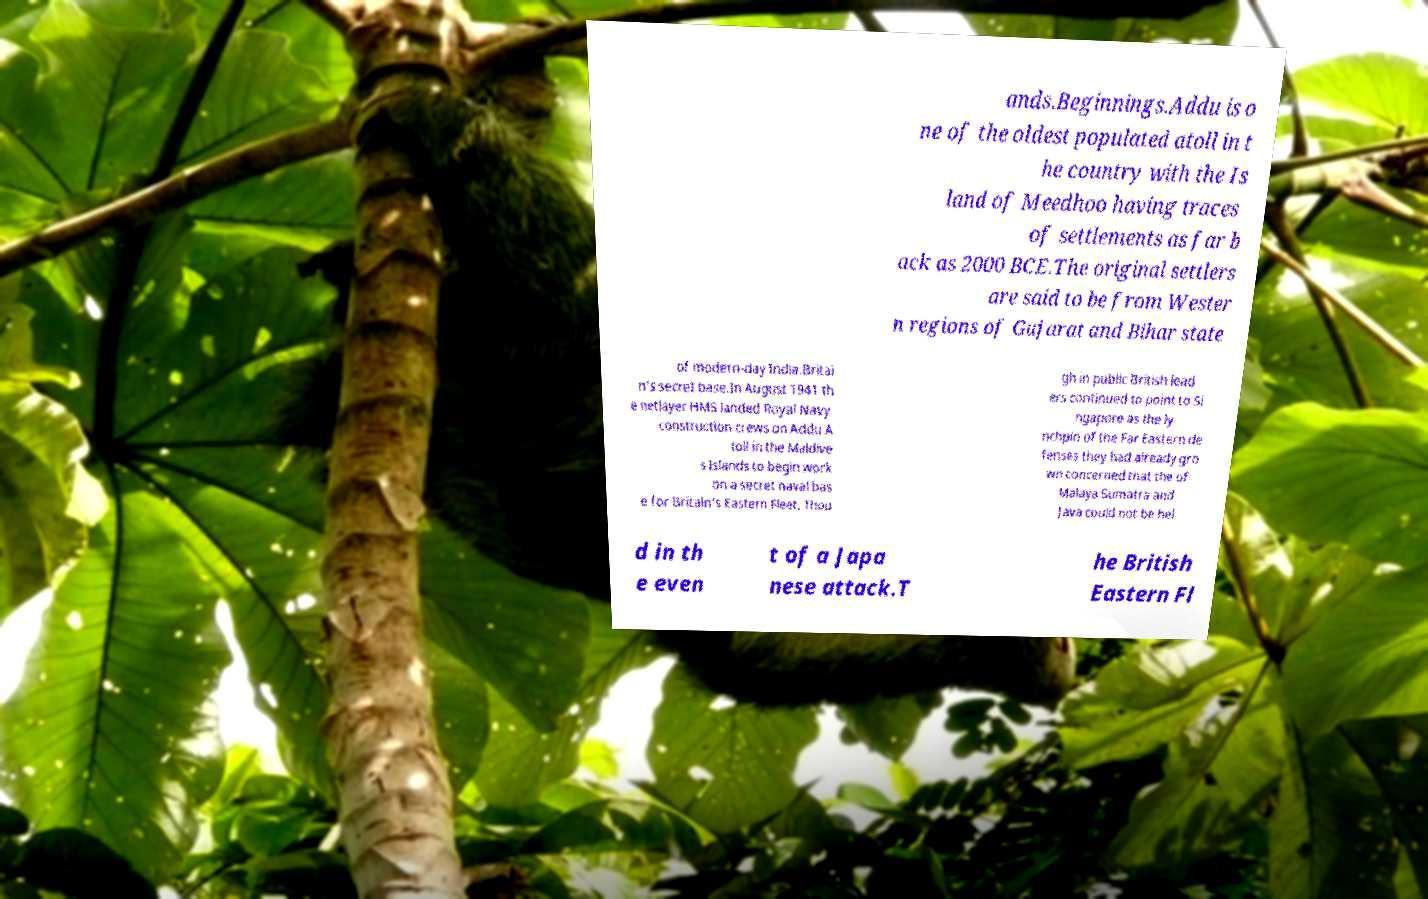Could you extract and type out the text from this image? ands.Beginnings.Addu is o ne of the oldest populated atoll in t he country with the Is land of Meedhoo having traces of settlements as far b ack as 2000 BCE.The original settlers are said to be from Wester n regions of Gujarat and Bihar state of modern-day India.Britai n's secret base.In August 1941 th e netlayer HMS landed Royal Navy construction crews on Addu A toll in the Maldive s Islands to begin work on a secret naval bas e for Britain's Eastern Fleet. Thou gh in public British lead ers continued to point to Si ngapore as the ly nchpin of the Far Eastern de fenses they had already gro wn concerned that the of Malaya Sumatra and Java could not be hel d in th e even t of a Japa nese attack.T he British Eastern Fl 